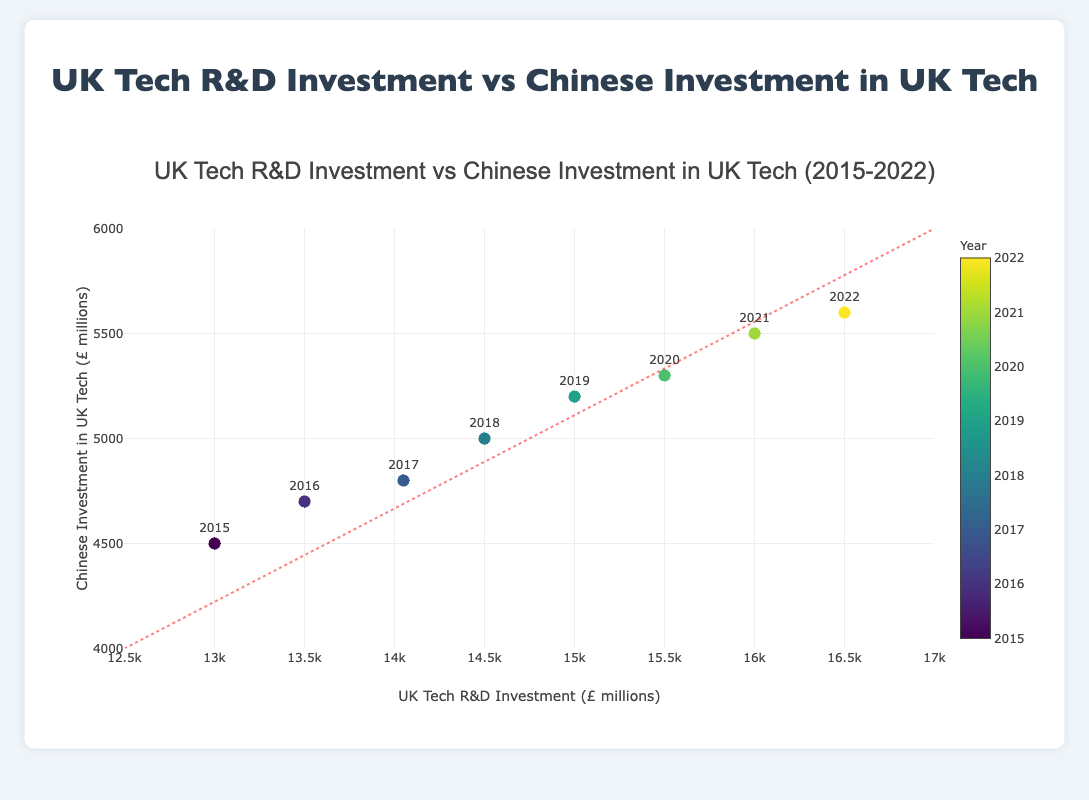What's the title of the scatter plot? The title of the scatter plot is located at the top of the figure where it provides an overview of the data presented. It reads "UK Tech R&D Investment vs Chinese Investment in UK Tech (2015-2022)."
Answer: UK Tech R&D Investment vs Chinese Investment in UK Tech (2015-2022) How many data points are displayed in the scatter plot? Each year from 2015 to 2022 is represented by a data point. By counting these markers, we can determine the total number of data points shown in the plot.
Answer: 8 Which year had the highest Chinese investment in UK tech? Inspect the scatter plot to find the data point where the y-axis value (Chinese Investment in UK Tech) is at its maximum. The colour and the text label will indicate the specific year. In this case, the highest point is for the year 2022.
Answer: 2022 What's the range of UK Tech R&D Investment displayed on the x-axis? The x-axis represents the UK Tech R&D Investment, and its range is given in the axis labels. It starts from £12,500 million and ends at £17,000 million, as indicated in the plot.
Answer: £12,500 million to £17,000 million Compare the UK Tech R&D Investment between 2015 and 2021. Which year had higher investment and by how much? Locate the data points for the years 2015 and 2021 on the x-axis to compare their values. In 2015, the investment was £13,000 million, and in 2021, it was £16,000 million. The difference is £16,000 million - £13,000 million = £3,000 million.
Answer: 2021, by £3,000 million What trend do you observe between UK Tech R&D Investment and Chinese Investment in UK Tech over the years? The scatter plot generally shows an increasing trend from left to right, indicating a positive correlation: as UK Tech R&D Investment increases, Chinese Investment also tends to increase. This suggests that higher UK investments might be attracting more Chinese investments or vice versa.
Answer: Positive correlation Are there any shapes or lines added to the plot? If yes, describe them. In addition to the data points, a dashed line is added that runs diagonally from the bottom-left corner towards the top-right. This line may represent a trend or a reference for comparison.
Answer: A dashed diagonal line What is the average Chinese investment in UK tech over the years presented? Sum all the y-axis values (Chinese Investment in UK Tech) and divide by the number of data points (from 2015-2022): (4500 + 4700 + 4800 + 5000 + 5200 + 5300 + 5500 + 5600) / 8 = 44,600 / 8 = 5,575 million.
Answer: £5,575 million Which colour scale is used to represent the years of the data points? The scatter plot uses the Viridis colour scale, as indicated in the marker properties on the figure. Colours transition smoothly, indicating different years.
Answer: Viridis What is the relationship between the UK Tech R&D Investment in 2018 and Chinese Investment in the same year? Look at the data point for 2018 on the plot. The x-axis (UK Tech R&D Investment) shows £14,500 million, and the y-axis (Chinese Investment in UK Tech) shows £5,000 million, which helps in understanding how much Chinese investment corresponds to the particular UK investment in that year.
Answer: £14,500 million and £5,000 million 